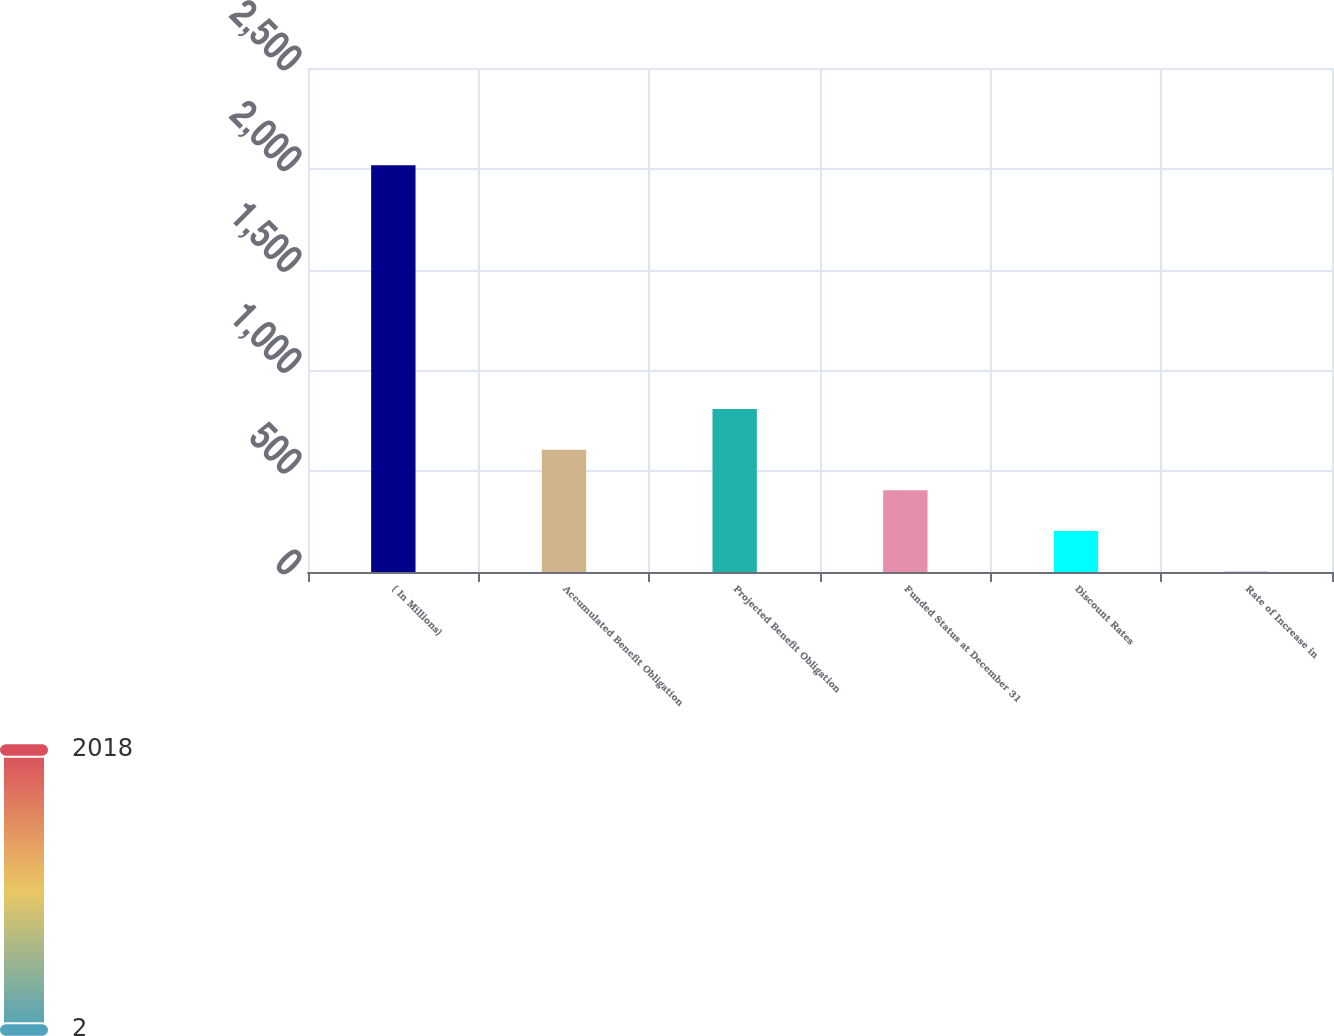Convert chart. <chart><loc_0><loc_0><loc_500><loc_500><bar_chart><fcel>( In Millions)<fcel>Accumulated Benefit Obligation<fcel>Projected Benefit Obligation<fcel>Funded Status at December 31<fcel>Discount Rates<fcel>Rate of Increase in<nl><fcel>2018<fcel>606.62<fcel>808.25<fcel>405<fcel>203.38<fcel>1.75<nl></chart> 